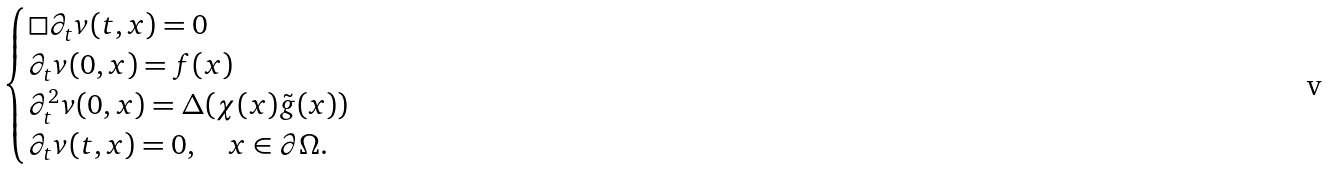Convert formula to latex. <formula><loc_0><loc_0><loc_500><loc_500>\begin{cases} \Box \partial _ { t } v ( t , x ) = 0 \\ \partial _ { t } v ( 0 , x ) = f ( x ) \\ \partial _ { t } ^ { 2 } v ( 0 , x ) = \Delta ( \chi ( x ) \tilde { g } ( x ) ) \\ \partial _ { t } v ( t , x ) = 0 , \quad x \in \partial \Omega . \end{cases}</formula> 